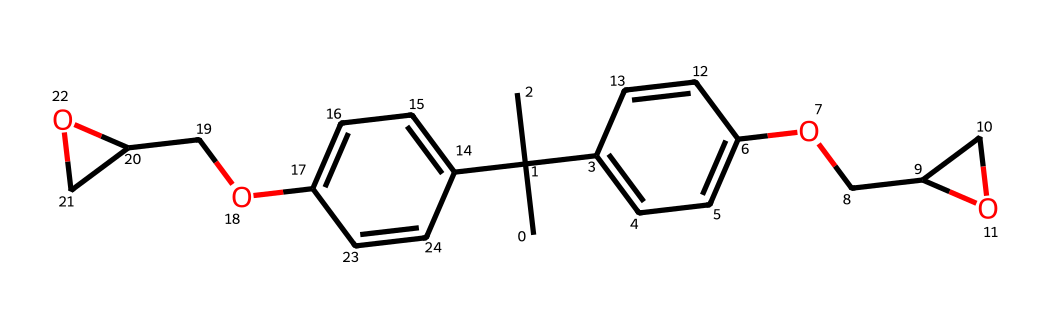How many carbon atoms are present in the structure? By examining the SMILES representation, we can count each 'C' in the structure, accounting for branches and cycles, which shows there are a total of 18 carbon atoms.
Answer: 18 What functional groups can be identified in this chemical? The chemical structure indicates the presence of two ether groups (–O–) connecting the aromatic rings, identifiable by the 'O' within the chain.
Answer: ether groups How many hydroxyl (–OH) groups are present? Observing the structure, there are two instances where 'O' is directly connected to 'C' and indicates hydroxyl groups in the structure.
Answer: 2 What is the primary type of intermolecular forces expected in epoxy resin adhesives? Due to the presence of hydroxyl groups and ether connections, hydrogen bonding and Van der Waals forces are expected to dominate the intermolecular interactions in this chemical.
Answer: hydrogen bonding How does the molecular structure contribute to the adhesive properties? The presence of multiple reactive functional groups (such as hydroxyl groups) allows for strong bonding interactions when used in adhesion applications, enhancing its adhesive properties.
Answer: strong bonding interactions 